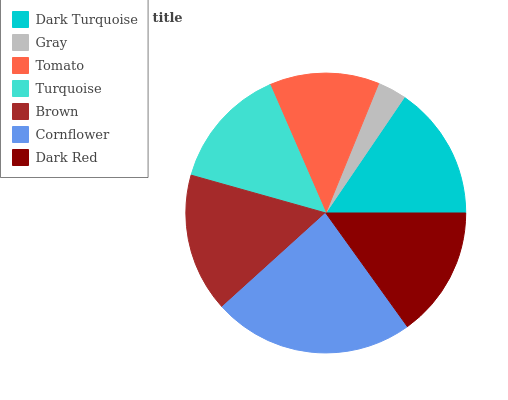Is Gray the minimum?
Answer yes or no. Yes. Is Cornflower the maximum?
Answer yes or no. Yes. Is Tomato the minimum?
Answer yes or no. No. Is Tomato the maximum?
Answer yes or no. No. Is Tomato greater than Gray?
Answer yes or no. Yes. Is Gray less than Tomato?
Answer yes or no. Yes. Is Gray greater than Tomato?
Answer yes or no. No. Is Tomato less than Gray?
Answer yes or no. No. Is Dark Red the high median?
Answer yes or no. Yes. Is Dark Red the low median?
Answer yes or no. Yes. Is Tomato the high median?
Answer yes or no. No. Is Brown the low median?
Answer yes or no. No. 